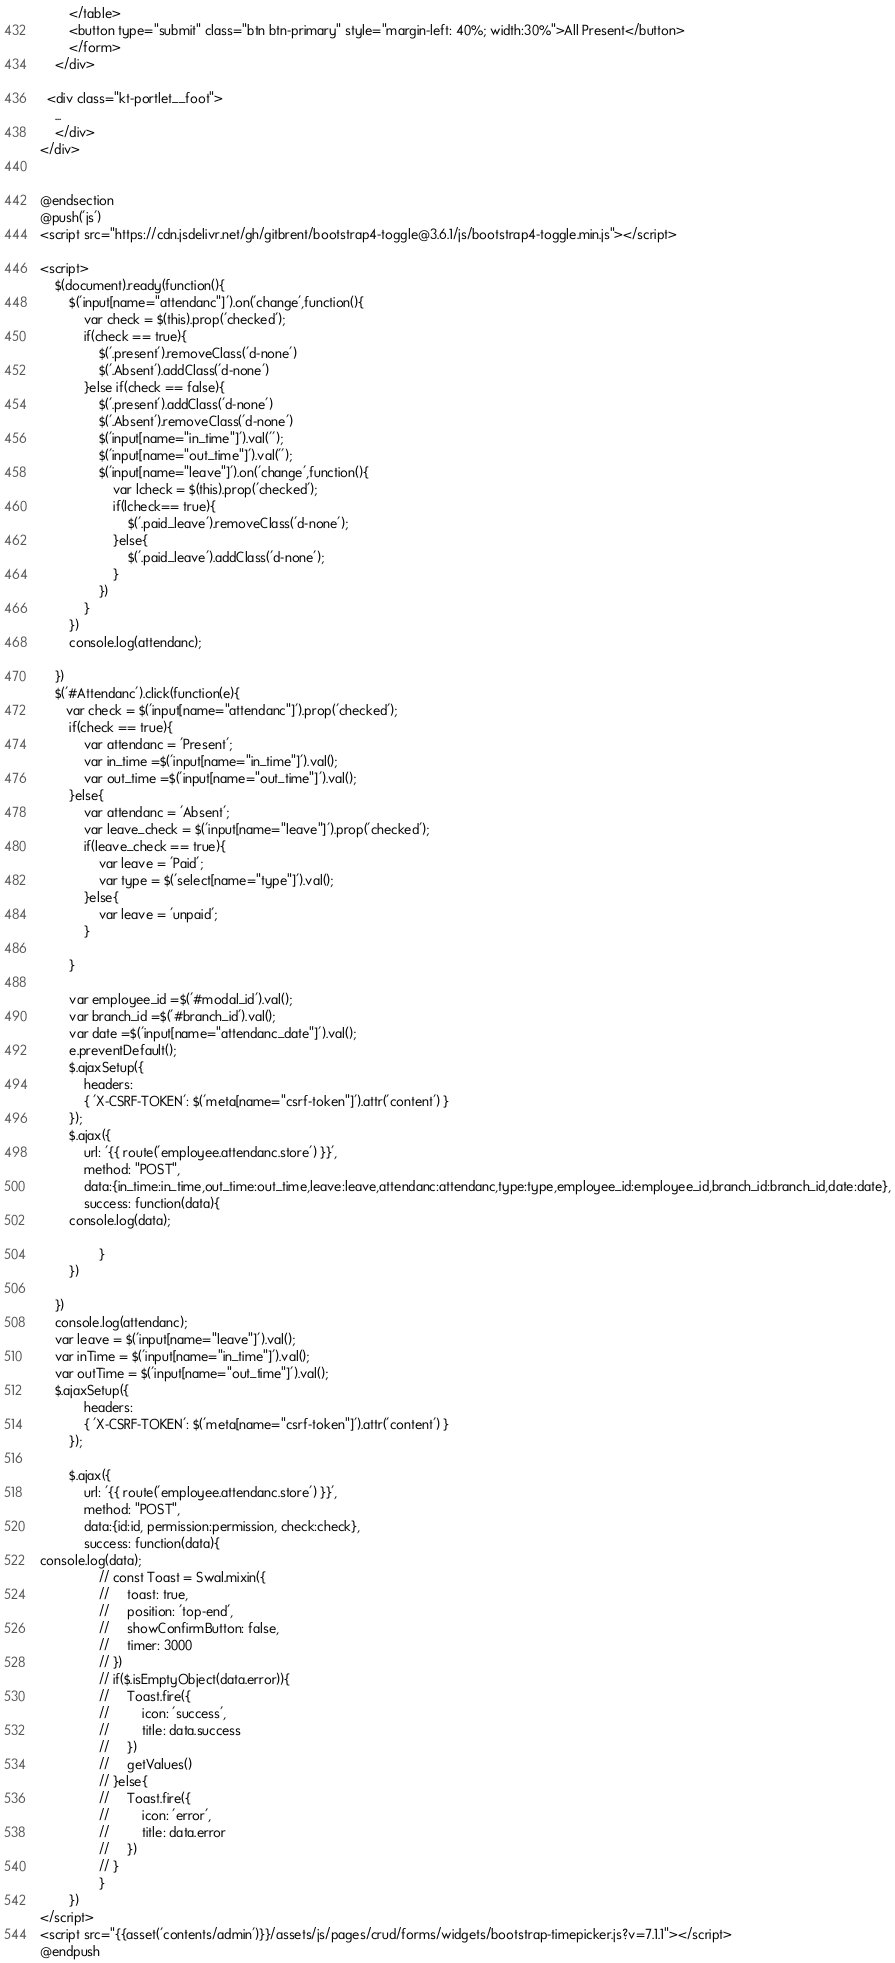<code> <loc_0><loc_0><loc_500><loc_500><_PHP_>        </table>
        <button type="submit" class="btn btn-primary" style="margin-left: 40%; width:30%">All Present</button>
        </form>
    </div>

  <div class="kt-portlet__foot">
    ...
	</div>
</div>


@endsection
@push('js')
<script src="https://cdn.jsdelivr.net/gh/gitbrent/bootstrap4-toggle@3.6.1/js/bootstrap4-toggle.min.js"></script>

<script>
    $(document).ready(function(){
        $('input[name="attendanc"]').on('change',function(){
            var check = $(this).prop('checked');
            if(check == true){
                $('.present').removeClass('d-none')
                $('.Absent').addClass('d-none')
            }else if(check == false){
                $('.present').addClass('d-none')
                $('.Absent').removeClass('d-none')
                $('input[name="in_time"]').val('');
                $('input[name="out_time"]').val('');
                $('input[name="leave"]').on('change',function(){
                    var lcheck = $(this).prop('checked');
                    if(lcheck== true){
                        $('.paid_leave').removeClass('d-none');
                    }else{
                        $('.paid_leave').addClass('d-none');
                    }
                })
            }
        })
        console.log(attendanc);

    })
    $('#Attendanc').click(function(e){
       var check = $('input[name="attendanc"]').prop('checked');
        if(check == true){
            var attendanc = 'Present';
            var in_time =$('input[name="in_time"]').val();
            var out_time =$('input[name="out_time"]').val();
        }else{
            var attendanc = 'Absent';
            var leave_check = $('input[name="leave"]').prop('checked');
            if(leave_check == true){
                var leave = 'Paid';
                var type = $('select[name="type"]').val();
            }else{
                var leave = 'unpaid';
            }

        }

        var employee_id =$('#modal_id').val();
        var branch_id =$('#branch_id').val();
        var date =$('input[name="attendanc_date"]').val();
        e.preventDefault();
        $.ajaxSetup({
            headers:
            { 'X-CSRF-TOKEN': $('meta[name="csrf-token"]').attr('content') }
        });
        $.ajax({
            url: '{{ route('employee.attendanc.store') }}',
            method: "POST",
            data:{in_time:in_time,out_time:out_time,leave:leave,attendanc:attendanc,type:type,employee_id:employee_id,branch_id:branch_id,date:date},
            success: function(data){
        console.log(data);

                }
        })

    })
    console.log(attendanc);
    var leave = $('input[name="leave"]').val();
    var inTime = $('input[name="in_time"]').val();
    var outTime = $('input[name="out_time"]').val();
    $.ajaxSetup({
            headers:
            { 'X-CSRF-TOKEN': $('meta[name="csrf-token"]').attr('content') }
        });

        $.ajax({
            url: '{{ route('employee.attendanc.store') }}',
            method: "POST",
            data:{id:id, permission:permission, check:check},
            success: function(data){
console.log(data);
                // const Toast = Swal.mixin({
                //     toast: true,
                //     position: 'top-end',
                //     showConfirmButton: false,
                //     timer: 3000
                // })
                // if($.isEmptyObject(data.error)){
                //     Toast.fire({
                //         icon: 'success',
                //         title: data.success
                //     })
                //     getValues()
                // }else{
                //     Toast.fire({
                //         icon: 'error',
                //         title: data.error
                //     })
                // }
                }
        })
</script>
<script src="{{asset('contents/admin')}}/assets/js/pages/crud/forms/widgets/bootstrap-timepicker.js?v=7.1.1"></script>
@endpush

</code> 